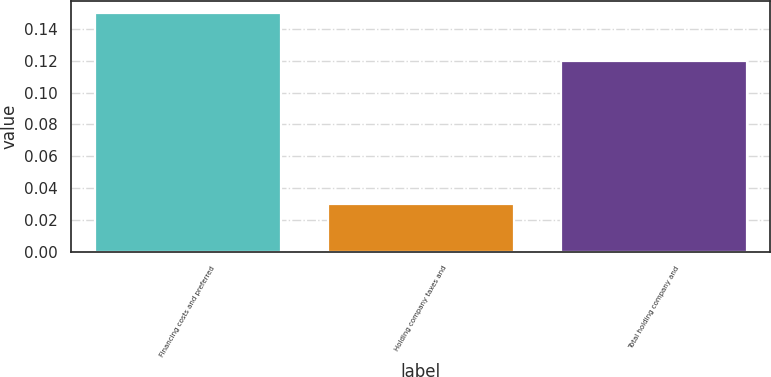<chart> <loc_0><loc_0><loc_500><loc_500><bar_chart><fcel>Financing costs and preferred<fcel>Holding company taxes and<fcel>Total holding company and<nl><fcel>0.15<fcel>0.03<fcel>0.12<nl></chart> 